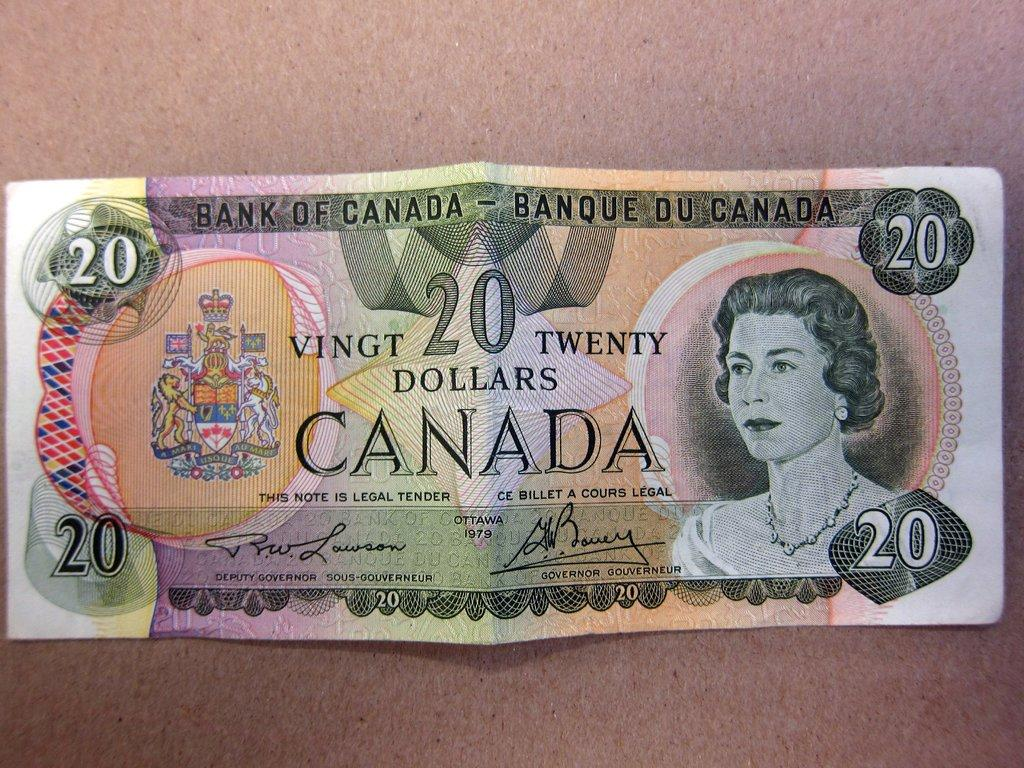What is the main subject in the center of the image? There is a currency note in the center of the image. What can be seen in the background of the image? There is a wall in the background of the image. What type of lace can be seen on the legs of the person in the image? There is no person present in the image, and therefore no legs or lace can be observed. 